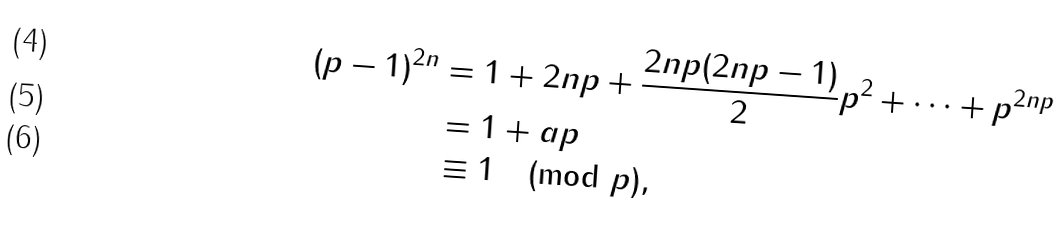Convert formula to latex. <formula><loc_0><loc_0><loc_500><loc_500>( p - 1 ) ^ { 2 n } & = 1 + 2 n p + \frac { 2 n p ( 2 n p - 1 ) } { 2 } p ^ { 2 } + \dots + p ^ { 2 n p } \\ & = 1 + a p \\ & \equiv 1 \pmod { p } ,</formula> 